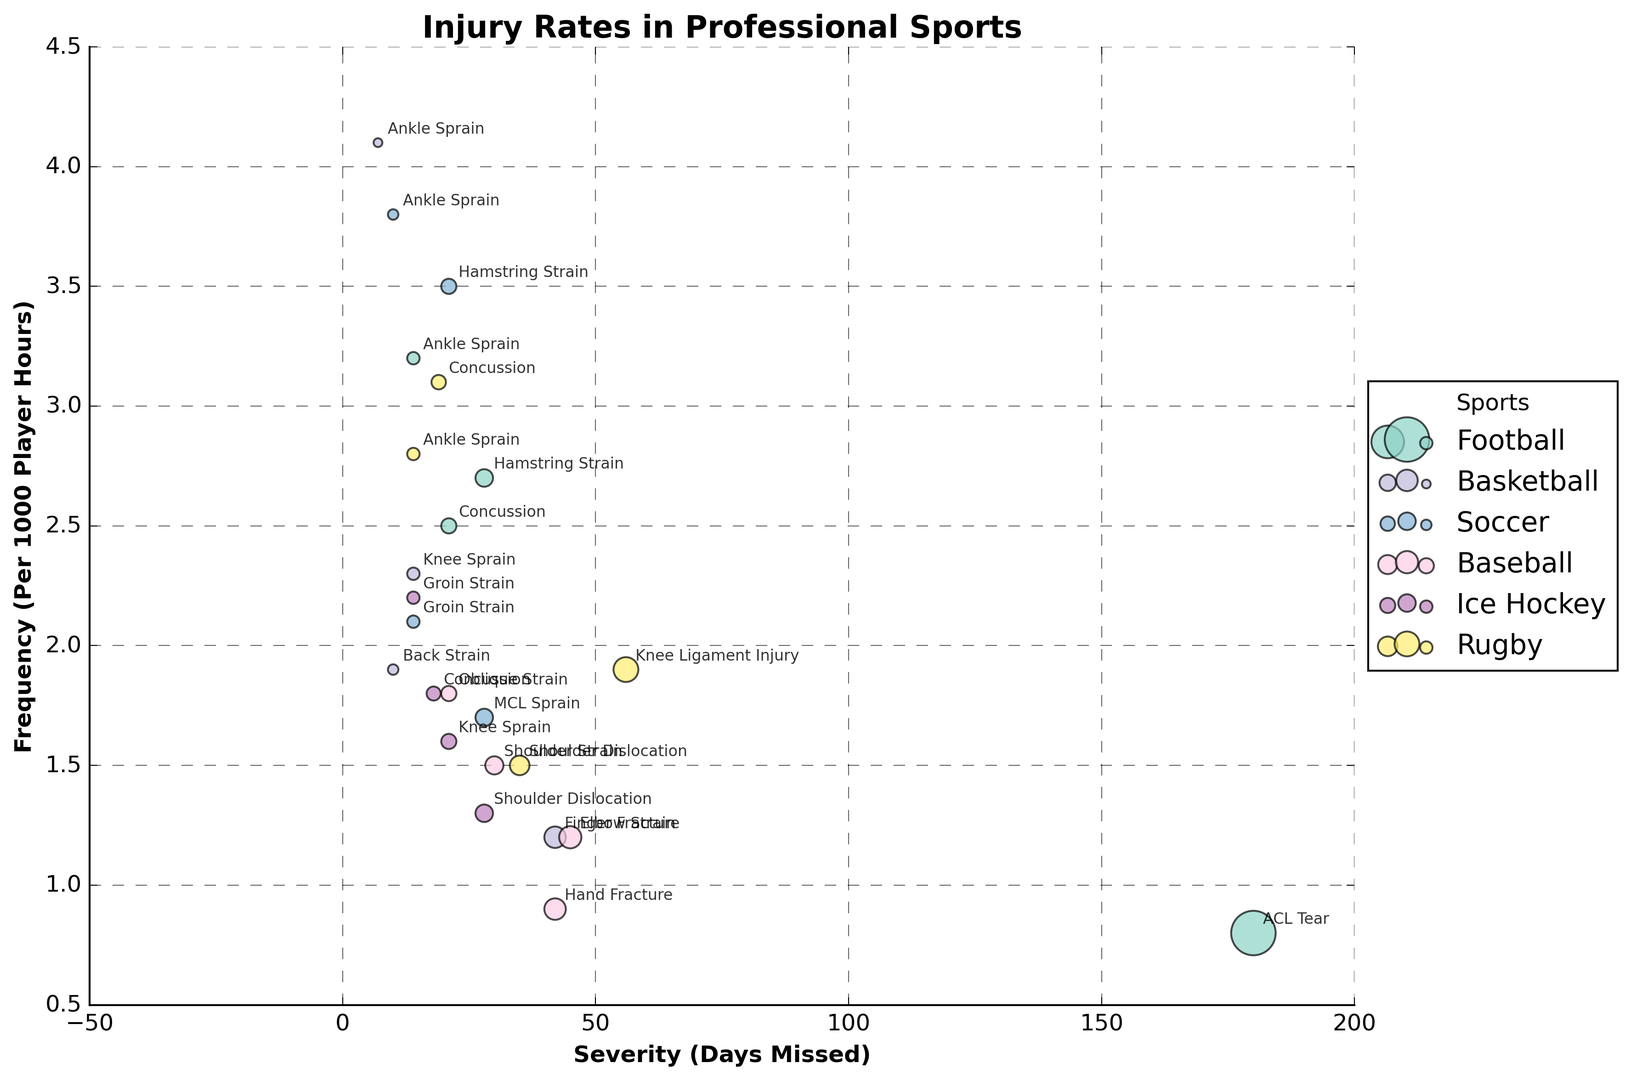Which sport has the highest frequency of Ankle Sprains? To find the sport with the highest frequency of Ankle Sprains, look for the bubble labeled "Ankle Sprain" and compare the frequency values. Football has a frequency of 3.2, Basketball has 4.1, Soccer has 3.8, and Rugby has 2.8. Basketball has the highest frequency.
Answer: Basketball Which sport has injuries with the highest average severity (Days Missed)? Calculate the average severity of injuries for each sport. Football (21+180+14+28)/4=60.75, Basketball (7+14+10+42)/4=18.25, Soccer (21+10+14+28)/4=18.25, Baseball (30+45+21+42)/4=34.5, Ice Hockey (18+28+21+14)/4=20.25, Rugby (19+56+35+14)/4=31.
Answer: Football Which injury type occurs most frequently in Soccer? Find the injury types and their frequencies in Soccer. Hamstring Strain (3.5), Ankle Sprain (3.8), Groin Strain (2.1), MCL Sprain (1.7). The highest frequency is 3.8 for Ankle Sprain.
Answer: Ankle Sprain Which sport has the smallest bubble in the chart, and what injury type does it represent? Identify the smallest bubble’s size by looking at the smallest circle. Hand Fracture for Baseball has a severity of 42 days missed and frequency of 0.9 per 1000 player hours.
Answer: Baseball, Hand Fracture Compare the frequency of Hamstring Strains between Football and Soccer. Which is higher? Look at the bubbles labeled "Hamstring Strain" for both sports, Football has a frequency of 2.7, and Soccer has 3.5. Soccer is higher.
Answer: Soccer Which sport appears to have more visually clustered data points? Examine the chart and observe which sport has more data points close to each other. Football's data points are more spread out, whereas Basketball and Soccer have more clustered points around low to mid severities and high frequencies.
Answer: Basketball/Soccer Compare the severity of Concussions across all sports. Which sport has the highest severity? Find the Concussion bubbles for each sport and compare their severity. Football (21), Ice Hockey (18), Rugby (19).
Answer: Football Which sports have injuries with a frequency of 2.5 or higher? Look for bubbles with a frequency of 2.5 or higher. Football (Concussion 2.5, Ankle Sprain 3.2, Hamstring Strain 2.7), Basketball (Ankle Sprain 4.1), Soccer (Hamstring Strain 3.5, Ankle Sprain 3.8), Rugby (Concussion 3.1, Ankle Sprain 2.8).
Answer: Football, Basketball, Soccer, Rugby Which injury type has the largest bubble in the chart? Determine the size of the bubbles according to their severity. ACL Tear in Football has the largest size because it has 180 days missed.
Answer: ACL Tear 